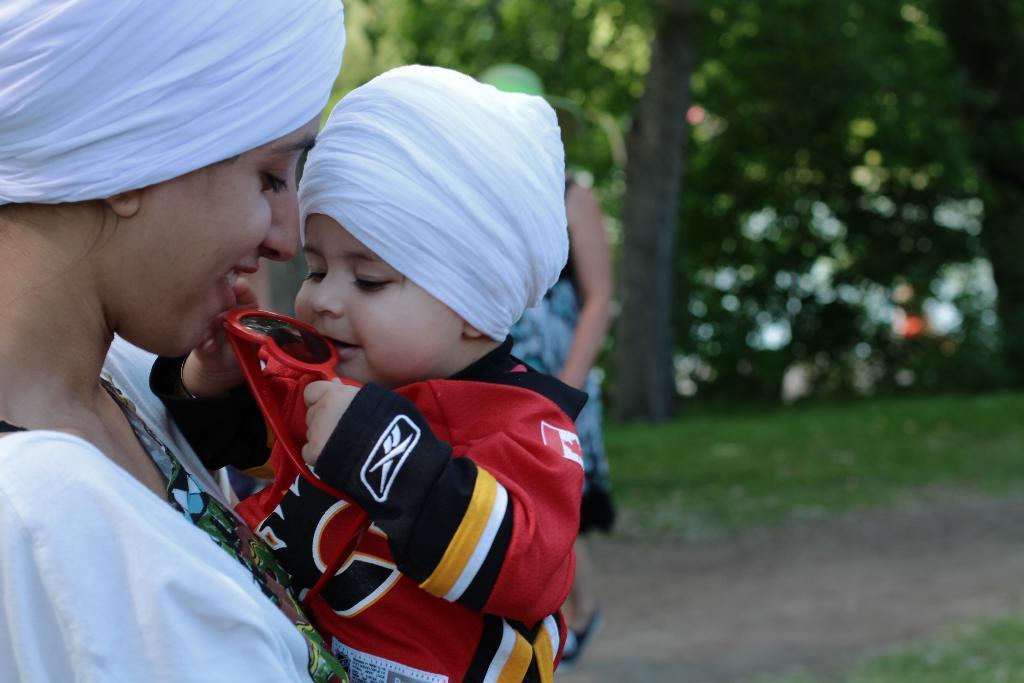Please provide a concise description of this image. In the image there is a woman in white dress and white turban holding a baby in red dress and white turban, in the back there is another lady visible, walking on the path with grass on either side and in the back there are trees. 